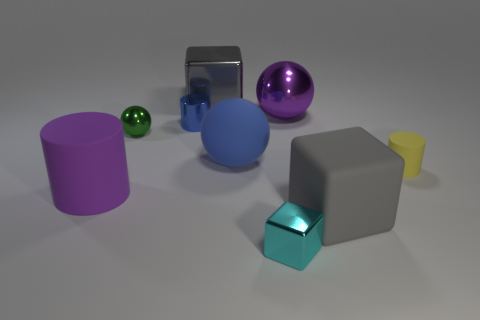Which of the objects in the image could float on water? Based on the objects' apparent materials and shapes, the yellow cup likely has the best chance to float due to its hollow structure and material that is commonly associated with buoyancy. 